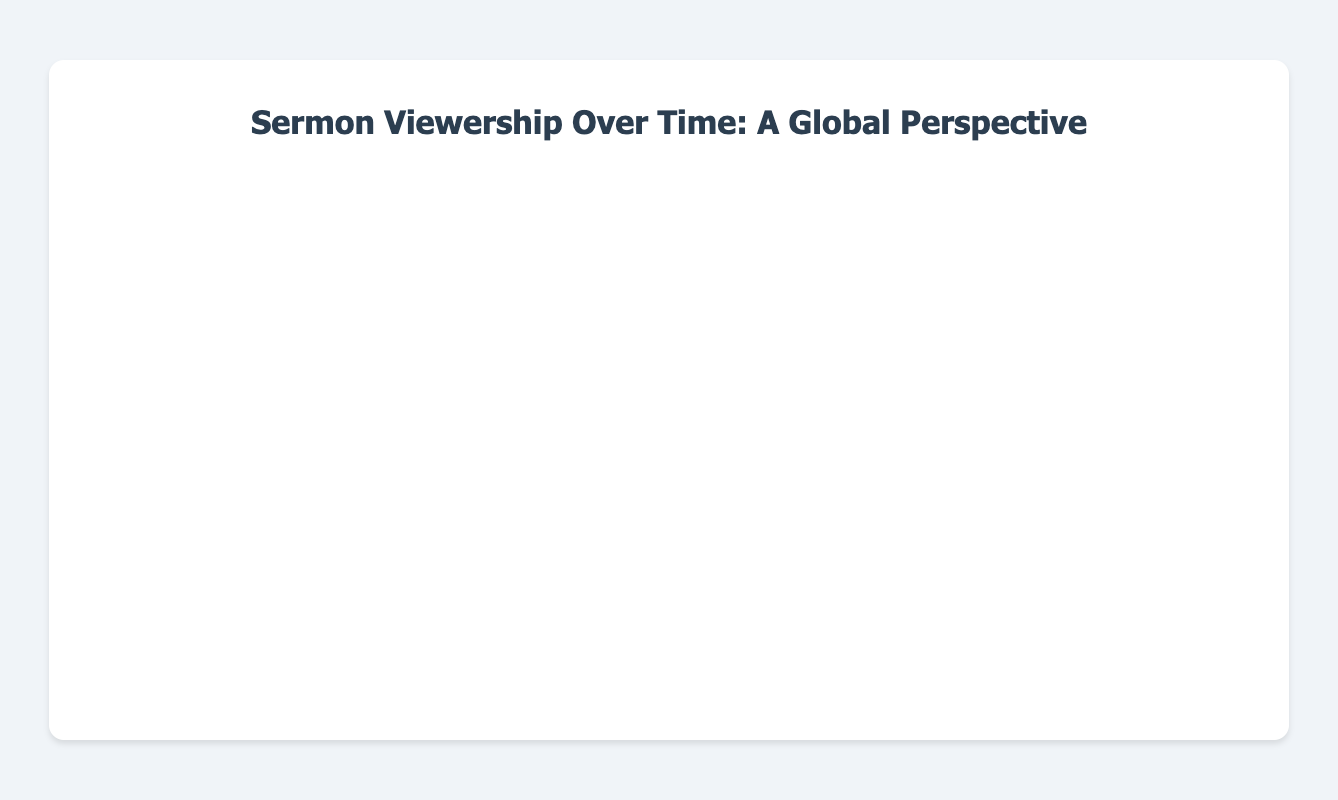What's the title of the chart? The title of the chart is displayed at the top of the figure, which reads "Sermon Viewership Over Time: A Global Perspective".
Answer: Sermon Viewership Over Time: A Global Perspective Which region had the highest number of viewers in January 2023? By observing the area chart for the month of January 2023, the region with the highest area (topmost line) is North America. It is mentioned with 5000 viewers.
Answer: North America How many total viewers were there in Asia in the entire period shown? To find the total viewers in Asia, sum the values for Asia across all months: 2000 + 2200 + 2400 + 2500 + 2600 + 2700 + 2800 + 2900 + 3000 + 3100 = 26200.
Answer: 26200 During which month did Africa reach 2000 viewers? By tracing the trendline for Africa and observing the viewers count, Africa reached 2000 viewers in July 2023.
Answer: July 2023 In which month did North America overtake 6000 viewers? By looking at the North America data points, it surpasses 6000 viewers in July 2023 with exactly 6000 viewers.
Answer: July 2023 Which two regions show the smallest difference in viewership in October 2023, and what is the difference? In October 2023, comparing the viewers for each region, Africa had 2300 viewers and South America had 1800 viewers. The difference is 2300 - 1800 = 500, which is the smallest difference among all regions.
Answer: Africa and South America, 500 By how much did the viewership in Europe increase from January 2023 to October 2023? Subtract the number of viewers in Europe in January 2023 from October 2023: 3900 - 3000 = 900 viewers.
Answer: 900 Which month saw the greatest increase in North American viewers since January 2023, and how large was the increase? By comparing each month's increase in North American viewers, August 2023 saw the greatest increase from the previous month (July) with an increase of 6200 - 6000 = 200.
Answer: August 2023, 200 What trend do we observe in South America’s viewership, and how stable is it compared to other regions? South America shows a steady and gradual increase in viewership, from 1200 in January to 1800 in October, suggesting a consistent but slower rise compared to other regions which show larger increments.
Answer: Steady and gradual increase Comparing overall viewership, which region consistently had the fewest viewers? Observing the area chart, South America consistently had the smallest area under its trendline, indicating it had the fewest viewers throughout the period.
Answer: South America 